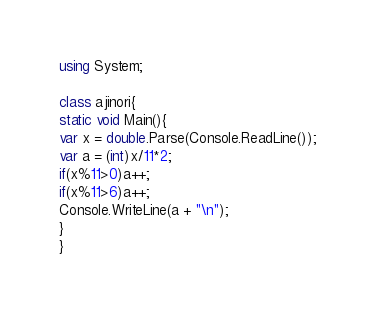<code> <loc_0><loc_0><loc_500><loc_500><_C#_>using System;

class ajinori{
static void Main(){
var x = double.Parse(Console.ReadLine());
var a = (int)x/11*2;
if(x%11>0)a++;
if(x%11>6)a++;
Console.WriteLine(a + "\n");
}
}</code> 